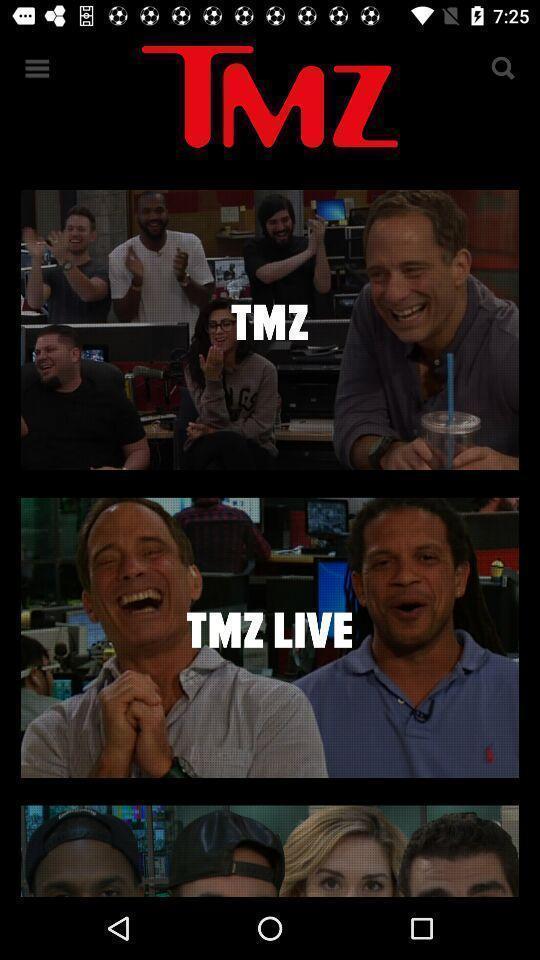What can you discern from this picture? Page showing exclusive and breaking celebrity news. 